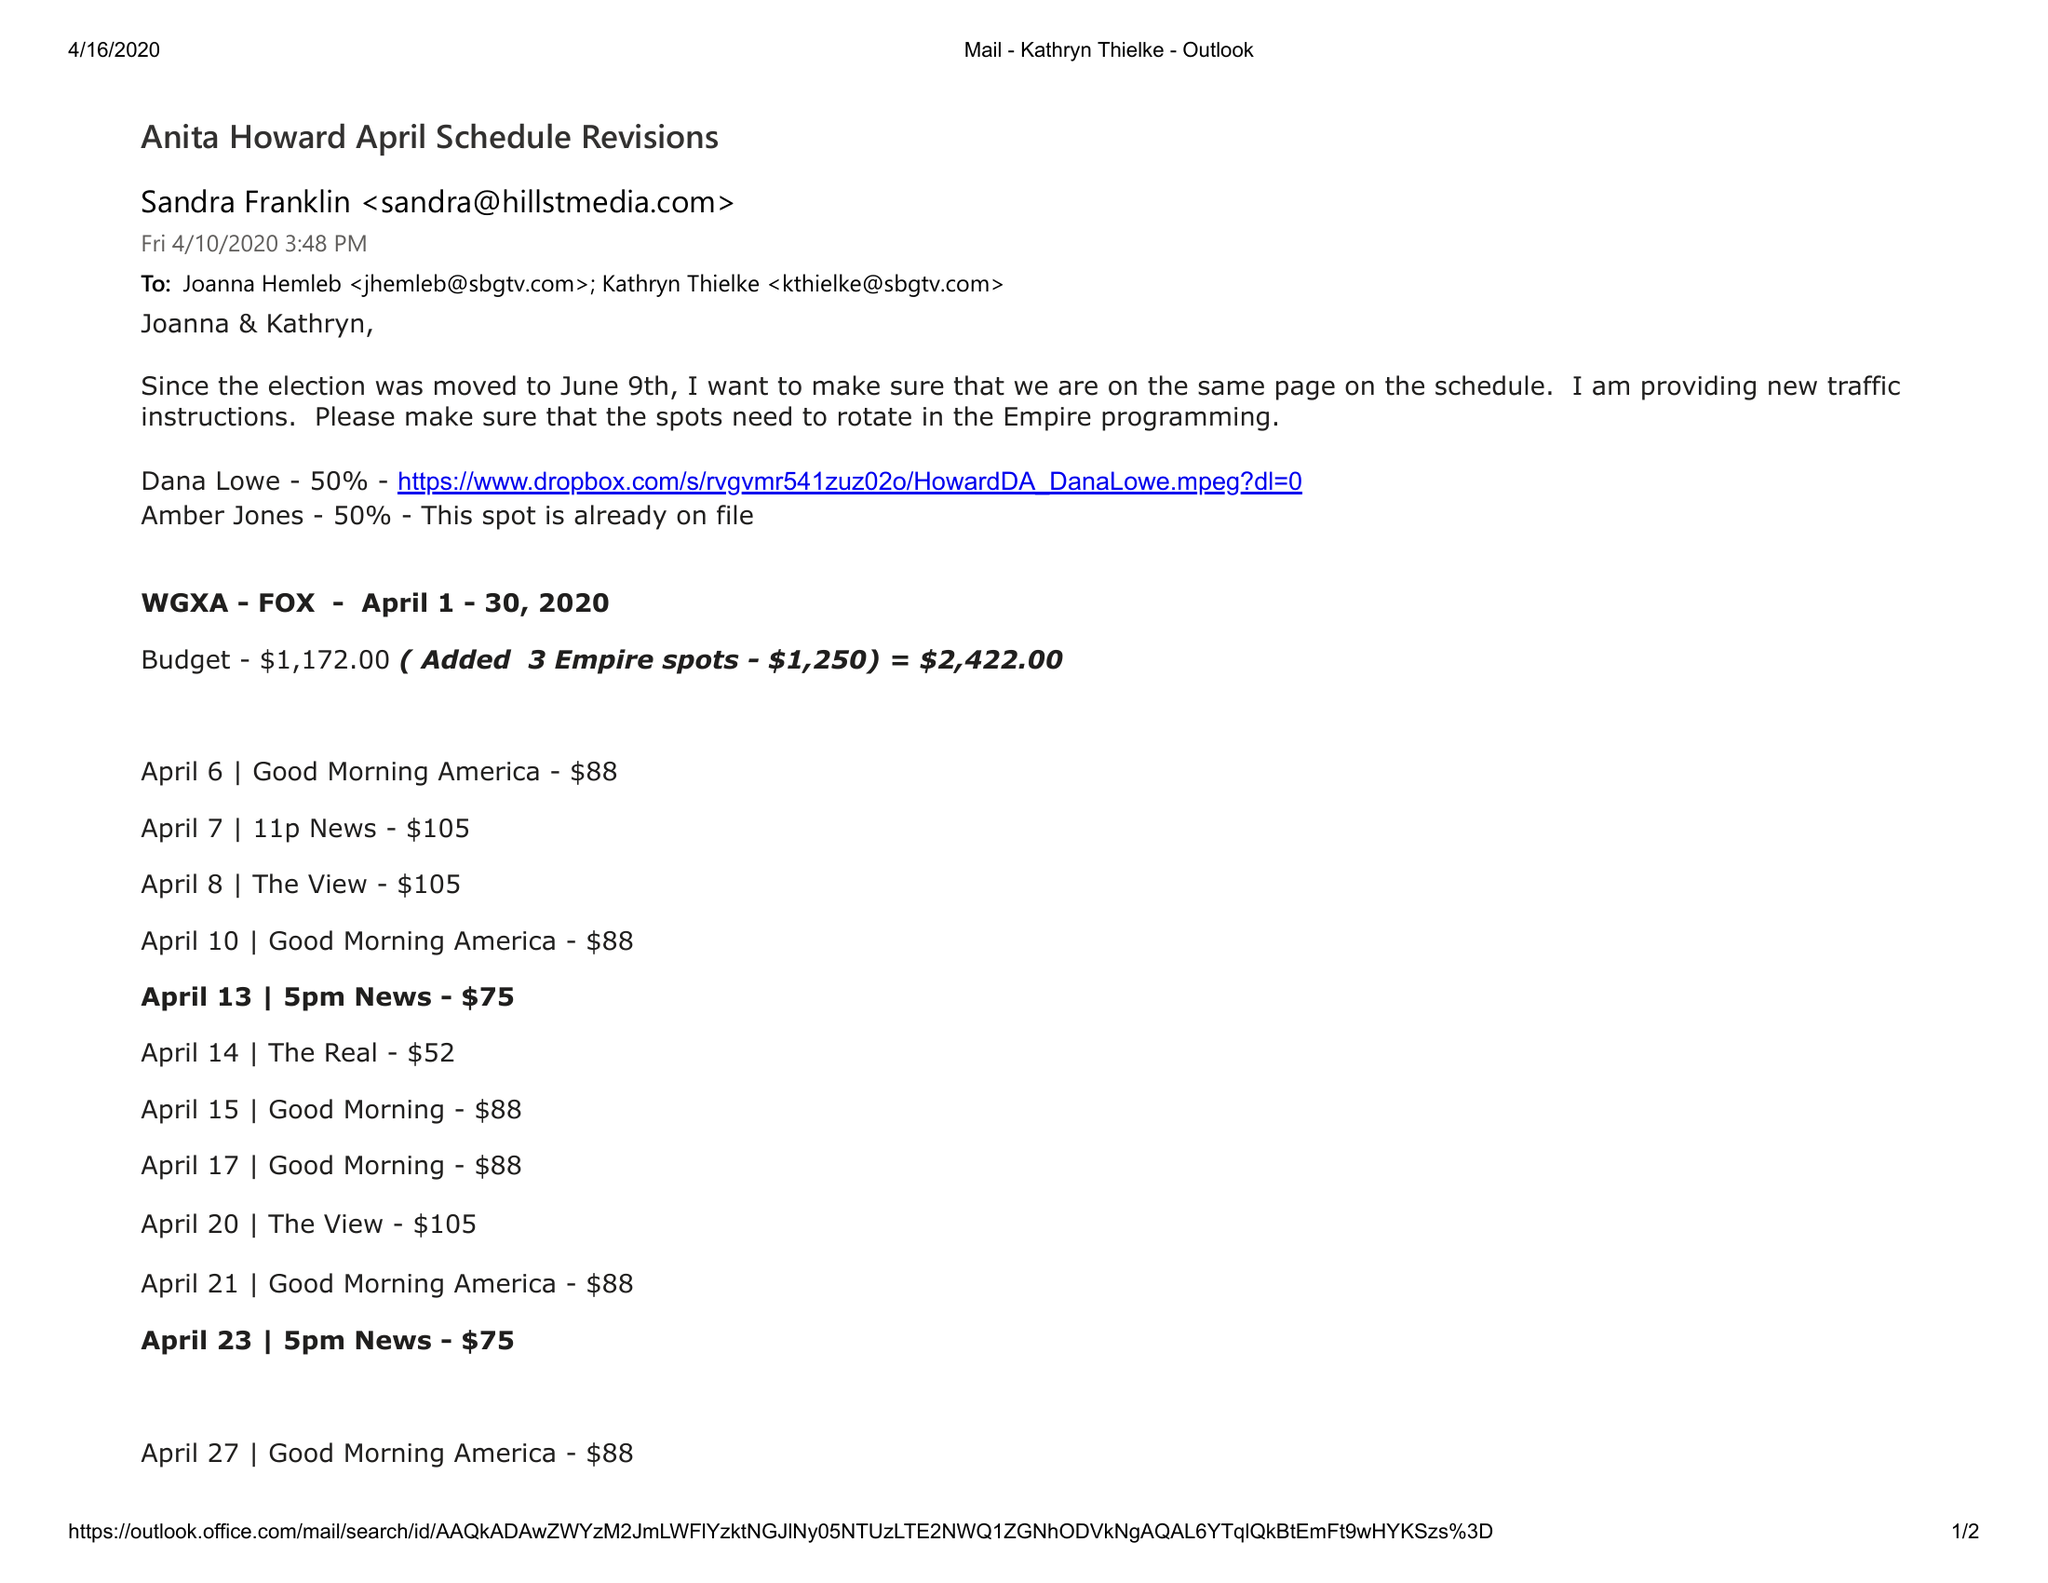What is the value for the gross_amount?
Answer the question using a single word or phrase. 2422.00 